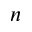Convert formula to latex. <formula><loc_0><loc_0><loc_500><loc_500>n</formula> 